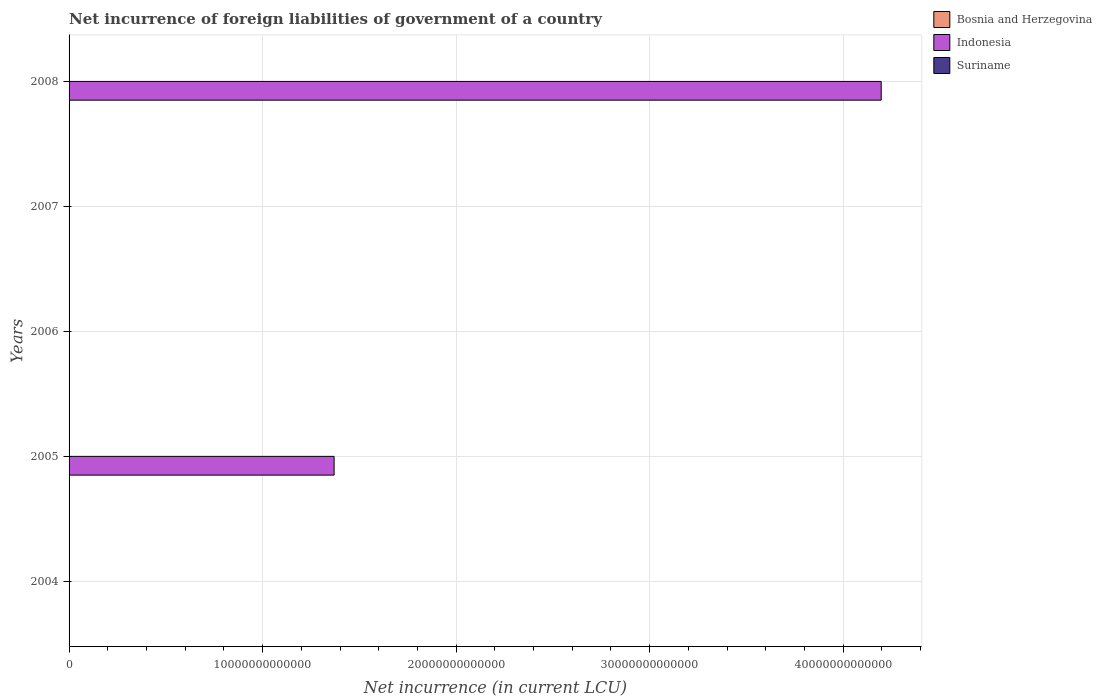How many bars are there on the 2nd tick from the bottom?
Give a very brief answer. 3. What is the net incurrence of foreign liabilities in Indonesia in 2006?
Your answer should be compact. 0. Across all years, what is the maximum net incurrence of foreign liabilities in Indonesia?
Your response must be concise. 4.20e+13. What is the total net incurrence of foreign liabilities in Suriname in the graph?
Provide a succinct answer. 6.59e+07. What is the difference between the net incurrence of foreign liabilities in Bosnia and Herzegovina in 2005 and that in 2008?
Give a very brief answer. -6.05e+07. What is the difference between the net incurrence of foreign liabilities in Indonesia in 2005 and the net incurrence of foreign liabilities in Bosnia and Herzegovina in 2007?
Your answer should be compact. 1.37e+13. What is the average net incurrence of foreign liabilities in Bosnia and Herzegovina per year?
Your answer should be very brief. 9.37e+07. In the year 2008, what is the difference between the net incurrence of foreign liabilities in Indonesia and net incurrence of foreign liabilities in Suriname?
Your answer should be compact. 4.20e+13. What is the ratio of the net incurrence of foreign liabilities in Bosnia and Herzegovina in 2004 to that in 2006?
Keep it short and to the point. 11.12. What is the difference between the highest and the lowest net incurrence of foreign liabilities in Suriname?
Keep it short and to the point. 3.38e+07. In how many years, is the net incurrence of foreign liabilities in Bosnia and Herzegovina greater than the average net incurrence of foreign liabilities in Bosnia and Herzegovina taken over all years?
Offer a terse response. 3. Are all the bars in the graph horizontal?
Provide a succinct answer. Yes. How many years are there in the graph?
Provide a short and direct response. 5. What is the difference between two consecutive major ticks on the X-axis?
Keep it short and to the point. 1.00e+13. Does the graph contain grids?
Make the answer very short. Yes. Where does the legend appear in the graph?
Your answer should be compact. Top right. What is the title of the graph?
Ensure brevity in your answer.  Net incurrence of foreign liabilities of government of a country. Does "Georgia" appear as one of the legend labels in the graph?
Give a very brief answer. No. What is the label or title of the X-axis?
Your answer should be compact. Net incurrence (in current LCU). What is the Net incurrence (in current LCU) in Bosnia and Herzegovina in 2004?
Make the answer very short. 1.36e+08. What is the Net incurrence (in current LCU) in Suriname in 2004?
Keep it short and to the point. 0. What is the Net incurrence (in current LCU) of Bosnia and Herzegovina in 2005?
Offer a terse response. 9.44e+07. What is the Net incurrence (in current LCU) of Indonesia in 2005?
Provide a succinct answer. 1.37e+13. What is the Net incurrence (in current LCU) of Suriname in 2005?
Ensure brevity in your answer.  3.21e+07. What is the Net incurrence (in current LCU) of Bosnia and Herzegovina in 2006?
Offer a very short reply. 1.23e+07. What is the Net incurrence (in current LCU) in Indonesia in 2006?
Offer a very short reply. 0. What is the Net incurrence (in current LCU) of Bosnia and Herzegovina in 2007?
Keep it short and to the point. 7.06e+07. What is the Net incurrence (in current LCU) of Suriname in 2007?
Offer a terse response. 0. What is the Net incurrence (in current LCU) of Bosnia and Herzegovina in 2008?
Give a very brief answer. 1.55e+08. What is the Net incurrence (in current LCU) of Indonesia in 2008?
Your answer should be very brief. 4.20e+13. What is the Net incurrence (in current LCU) in Suriname in 2008?
Offer a very short reply. 3.38e+07. Across all years, what is the maximum Net incurrence (in current LCU) of Bosnia and Herzegovina?
Your answer should be very brief. 1.55e+08. Across all years, what is the maximum Net incurrence (in current LCU) of Indonesia?
Make the answer very short. 4.20e+13. Across all years, what is the maximum Net incurrence (in current LCU) in Suriname?
Offer a very short reply. 3.38e+07. Across all years, what is the minimum Net incurrence (in current LCU) in Bosnia and Herzegovina?
Give a very brief answer. 1.23e+07. Across all years, what is the minimum Net incurrence (in current LCU) of Indonesia?
Offer a terse response. 0. What is the total Net incurrence (in current LCU) in Bosnia and Herzegovina in the graph?
Your answer should be very brief. 4.68e+08. What is the total Net incurrence (in current LCU) of Indonesia in the graph?
Provide a short and direct response. 5.57e+13. What is the total Net incurrence (in current LCU) of Suriname in the graph?
Provide a short and direct response. 6.59e+07. What is the difference between the Net incurrence (in current LCU) of Bosnia and Herzegovina in 2004 and that in 2005?
Offer a very short reply. 4.19e+07. What is the difference between the Net incurrence (in current LCU) in Bosnia and Herzegovina in 2004 and that in 2006?
Make the answer very short. 1.24e+08. What is the difference between the Net incurrence (in current LCU) in Bosnia and Herzegovina in 2004 and that in 2007?
Your answer should be very brief. 6.57e+07. What is the difference between the Net incurrence (in current LCU) of Bosnia and Herzegovina in 2004 and that in 2008?
Your answer should be very brief. -1.86e+07. What is the difference between the Net incurrence (in current LCU) in Bosnia and Herzegovina in 2005 and that in 2006?
Keep it short and to the point. 8.22e+07. What is the difference between the Net incurrence (in current LCU) of Bosnia and Herzegovina in 2005 and that in 2007?
Offer a terse response. 2.38e+07. What is the difference between the Net incurrence (in current LCU) of Bosnia and Herzegovina in 2005 and that in 2008?
Offer a very short reply. -6.05e+07. What is the difference between the Net incurrence (in current LCU) of Indonesia in 2005 and that in 2008?
Your response must be concise. -2.83e+13. What is the difference between the Net incurrence (in current LCU) in Suriname in 2005 and that in 2008?
Ensure brevity in your answer.  -1.72e+06. What is the difference between the Net incurrence (in current LCU) of Bosnia and Herzegovina in 2006 and that in 2007?
Offer a very short reply. -5.84e+07. What is the difference between the Net incurrence (in current LCU) of Bosnia and Herzegovina in 2006 and that in 2008?
Provide a short and direct response. -1.43e+08. What is the difference between the Net incurrence (in current LCU) of Bosnia and Herzegovina in 2007 and that in 2008?
Offer a very short reply. -8.43e+07. What is the difference between the Net incurrence (in current LCU) of Bosnia and Herzegovina in 2004 and the Net incurrence (in current LCU) of Indonesia in 2005?
Give a very brief answer. -1.37e+13. What is the difference between the Net incurrence (in current LCU) of Bosnia and Herzegovina in 2004 and the Net incurrence (in current LCU) of Suriname in 2005?
Give a very brief answer. 1.04e+08. What is the difference between the Net incurrence (in current LCU) in Bosnia and Herzegovina in 2004 and the Net incurrence (in current LCU) in Indonesia in 2008?
Provide a short and direct response. -4.20e+13. What is the difference between the Net incurrence (in current LCU) in Bosnia and Herzegovina in 2004 and the Net incurrence (in current LCU) in Suriname in 2008?
Your answer should be very brief. 1.03e+08. What is the difference between the Net incurrence (in current LCU) in Bosnia and Herzegovina in 2005 and the Net incurrence (in current LCU) in Indonesia in 2008?
Your response must be concise. -4.20e+13. What is the difference between the Net incurrence (in current LCU) of Bosnia and Herzegovina in 2005 and the Net incurrence (in current LCU) of Suriname in 2008?
Keep it short and to the point. 6.06e+07. What is the difference between the Net incurrence (in current LCU) of Indonesia in 2005 and the Net incurrence (in current LCU) of Suriname in 2008?
Ensure brevity in your answer.  1.37e+13. What is the difference between the Net incurrence (in current LCU) in Bosnia and Herzegovina in 2006 and the Net incurrence (in current LCU) in Indonesia in 2008?
Offer a terse response. -4.20e+13. What is the difference between the Net incurrence (in current LCU) in Bosnia and Herzegovina in 2006 and the Net incurrence (in current LCU) in Suriname in 2008?
Provide a succinct answer. -2.15e+07. What is the difference between the Net incurrence (in current LCU) in Bosnia and Herzegovina in 2007 and the Net incurrence (in current LCU) in Indonesia in 2008?
Give a very brief answer. -4.20e+13. What is the difference between the Net incurrence (in current LCU) in Bosnia and Herzegovina in 2007 and the Net incurrence (in current LCU) in Suriname in 2008?
Make the answer very short. 3.68e+07. What is the average Net incurrence (in current LCU) in Bosnia and Herzegovina per year?
Offer a terse response. 9.37e+07. What is the average Net incurrence (in current LCU) of Indonesia per year?
Offer a very short reply. 1.11e+13. What is the average Net incurrence (in current LCU) in Suriname per year?
Offer a very short reply. 1.32e+07. In the year 2005, what is the difference between the Net incurrence (in current LCU) of Bosnia and Herzegovina and Net incurrence (in current LCU) of Indonesia?
Keep it short and to the point. -1.37e+13. In the year 2005, what is the difference between the Net incurrence (in current LCU) of Bosnia and Herzegovina and Net incurrence (in current LCU) of Suriname?
Ensure brevity in your answer.  6.23e+07. In the year 2005, what is the difference between the Net incurrence (in current LCU) of Indonesia and Net incurrence (in current LCU) of Suriname?
Your answer should be very brief. 1.37e+13. In the year 2008, what is the difference between the Net incurrence (in current LCU) of Bosnia and Herzegovina and Net incurrence (in current LCU) of Indonesia?
Provide a short and direct response. -4.20e+13. In the year 2008, what is the difference between the Net incurrence (in current LCU) in Bosnia and Herzegovina and Net incurrence (in current LCU) in Suriname?
Give a very brief answer. 1.21e+08. In the year 2008, what is the difference between the Net incurrence (in current LCU) of Indonesia and Net incurrence (in current LCU) of Suriname?
Ensure brevity in your answer.  4.20e+13. What is the ratio of the Net incurrence (in current LCU) of Bosnia and Herzegovina in 2004 to that in 2005?
Ensure brevity in your answer.  1.44. What is the ratio of the Net incurrence (in current LCU) of Bosnia and Herzegovina in 2004 to that in 2006?
Ensure brevity in your answer.  11.12. What is the ratio of the Net incurrence (in current LCU) of Bosnia and Herzegovina in 2004 to that in 2007?
Provide a short and direct response. 1.93. What is the ratio of the Net incurrence (in current LCU) of Bosnia and Herzegovina in 2004 to that in 2008?
Your response must be concise. 0.88. What is the ratio of the Net incurrence (in current LCU) of Bosnia and Herzegovina in 2005 to that in 2006?
Keep it short and to the point. 7.7. What is the ratio of the Net incurrence (in current LCU) in Bosnia and Herzegovina in 2005 to that in 2007?
Offer a very short reply. 1.34. What is the ratio of the Net incurrence (in current LCU) in Bosnia and Herzegovina in 2005 to that in 2008?
Make the answer very short. 0.61. What is the ratio of the Net incurrence (in current LCU) in Indonesia in 2005 to that in 2008?
Offer a very short reply. 0.33. What is the ratio of the Net incurrence (in current LCU) of Suriname in 2005 to that in 2008?
Provide a short and direct response. 0.95. What is the ratio of the Net incurrence (in current LCU) of Bosnia and Herzegovina in 2006 to that in 2007?
Ensure brevity in your answer.  0.17. What is the ratio of the Net incurrence (in current LCU) of Bosnia and Herzegovina in 2006 to that in 2008?
Provide a short and direct response. 0.08. What is the ratio of the Net incurrence (in current LCU) of Bosnia and Herzegovina in 2007 to that in 2008?
Keep it short and to the point. 0.46. What is the difference between the highest and the second highest Net incurrence (in current LCU) in Bosnia and Herzegovina?
Make the answer very short. 1.86e+07. What is the difference between the highest and the lowest Net incurrence (in current LCU) of Bosnia and Herzegovina?
Your response must be concise. 1.43e+08. What is the difference between the highest and the lowest Net incurrence (in current LCU) of Indonesia?
Make the answer very short. 4.20e+13. What is the difference between the highest and the lowest Net incurrence (in current LCU) in Suriname?
Make the answer very short. 3.38e+07. 